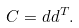<formula> <loc_0><loc_0><loc_500><loc_500>C = d d ^ { T } .</formula> 